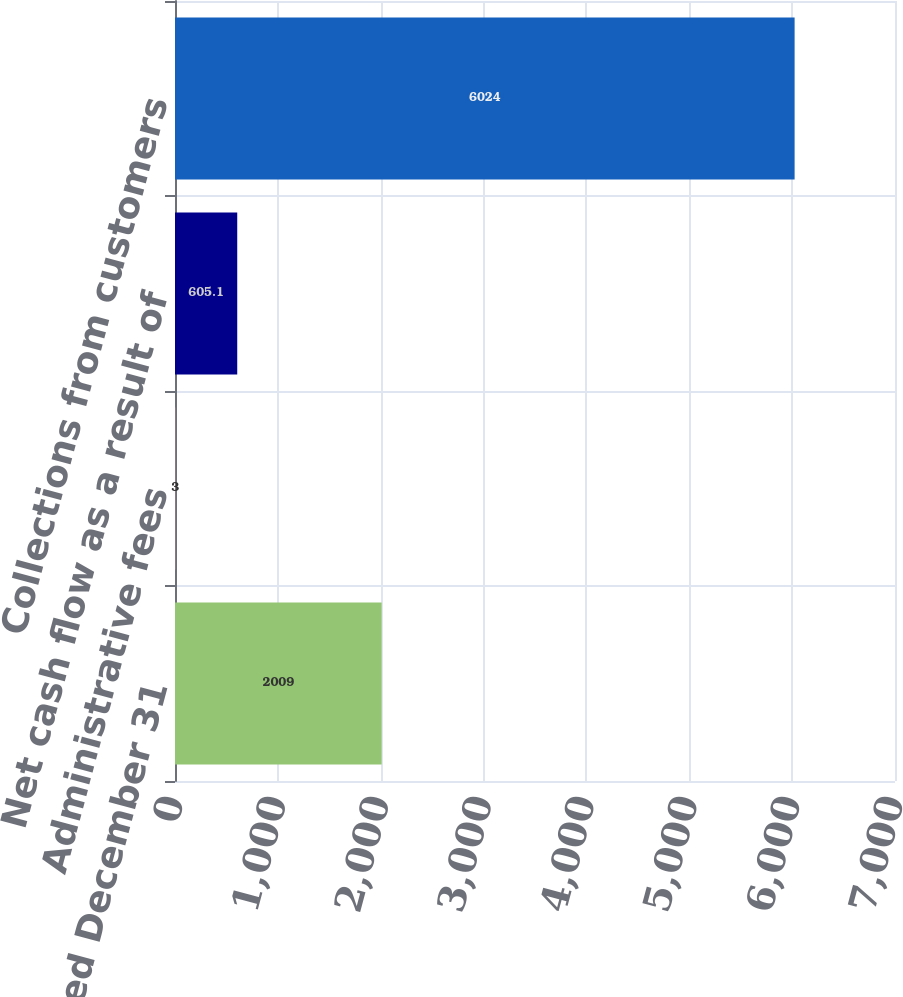<chart> <loc_0><loc_0><loc_500><loc_500><bar_chart><fcel>Years Ended December 31<fcel>Administrative fees<fcel>Net cash flow as a result of<fcel>Collections from customers<nl><fcel>2009<fcel>3<fcel>605.1<fcel>6024<nl></chart> 